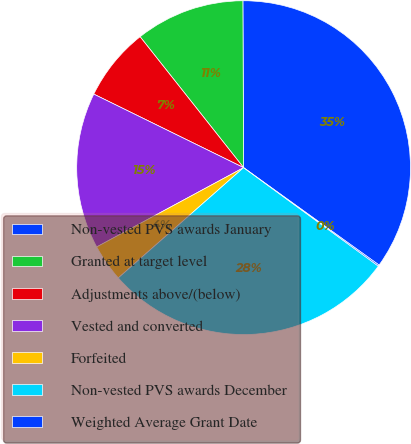Convert chart. <chart><loc_0><loc_0><loc_500><loc_500><pie_chart><fcel>Non-vested PVS awards January<fcel>Granted at target level<fcel>Adjustments above/(below)<fcel>Vested and converted<fcel>Forfeited<fcel>Non-vested PVS awards December<fcel>Weighted Average Grant Date<nl><fcel>34.99%<fcel>10.58%<fcel>7.09%<fcel>15.14%<fcel>3.61%<fcel>28.47%<fcel>0.12%<nl></chart> 